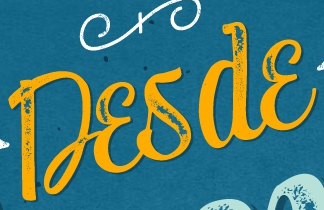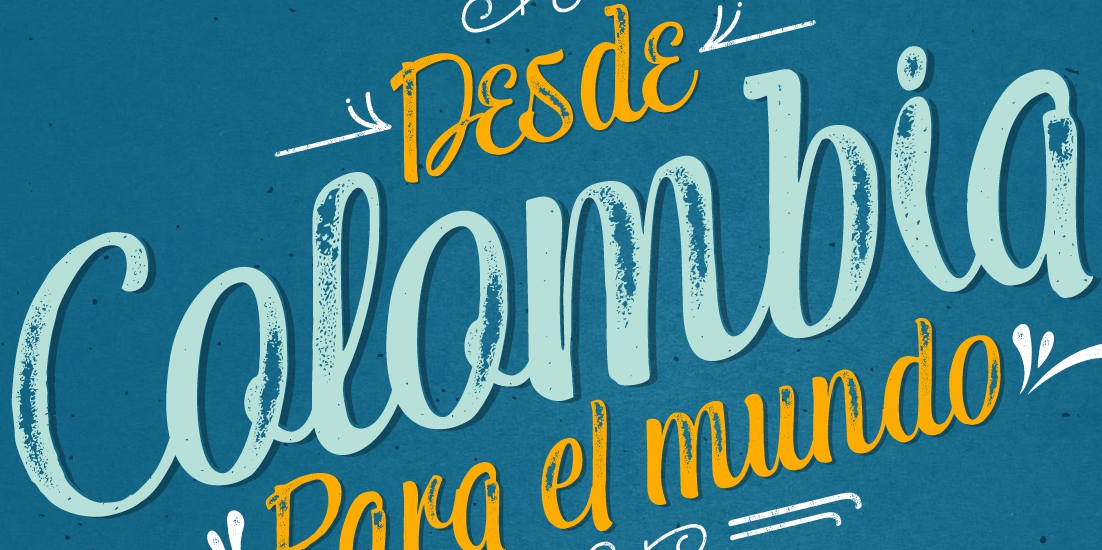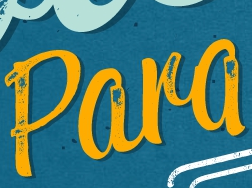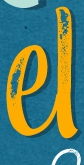What text appears in these images from left to right, separated by a semicolon? Desde; Colombia; Para; el 